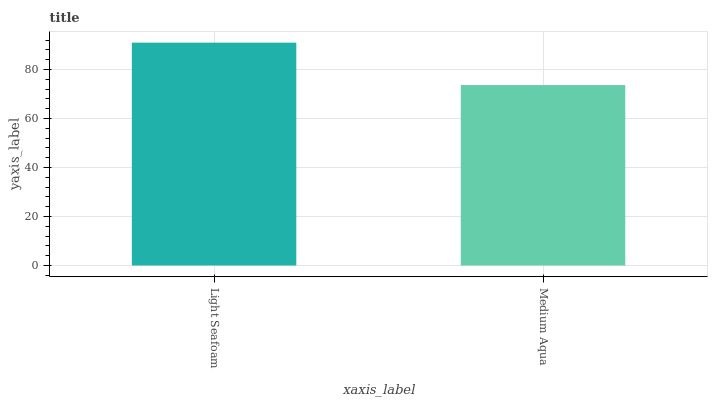Is Medium Aqua the minimum?
Answer yes or no. Yes. Is Light Seafoam the maximum?
Answer yes or no. Yes. Is Medium Aqua the maximum?
Answer yes or no. No. Is Light Seafoam greater than Medium Aqua?
Answer yes or no. Yes. Is Medium Aqua less than Light Seafoam?
Answer yes or no. Yes. Is Medium Aqua greater than Light Seafoam?
Answer yes or no. No. Is Light Seafoam less than Medium Aqua?
Answer yes or no. No. Is Light Seafoam the high median?
Answer yes or no. Yes. Is Medium Aqua the low median?
Answer yes or no. Yes. Is Medium Aqua the high median?
Answer yes or no. No. Is Light Seafoam the low median?
Answer yes or no. No. 